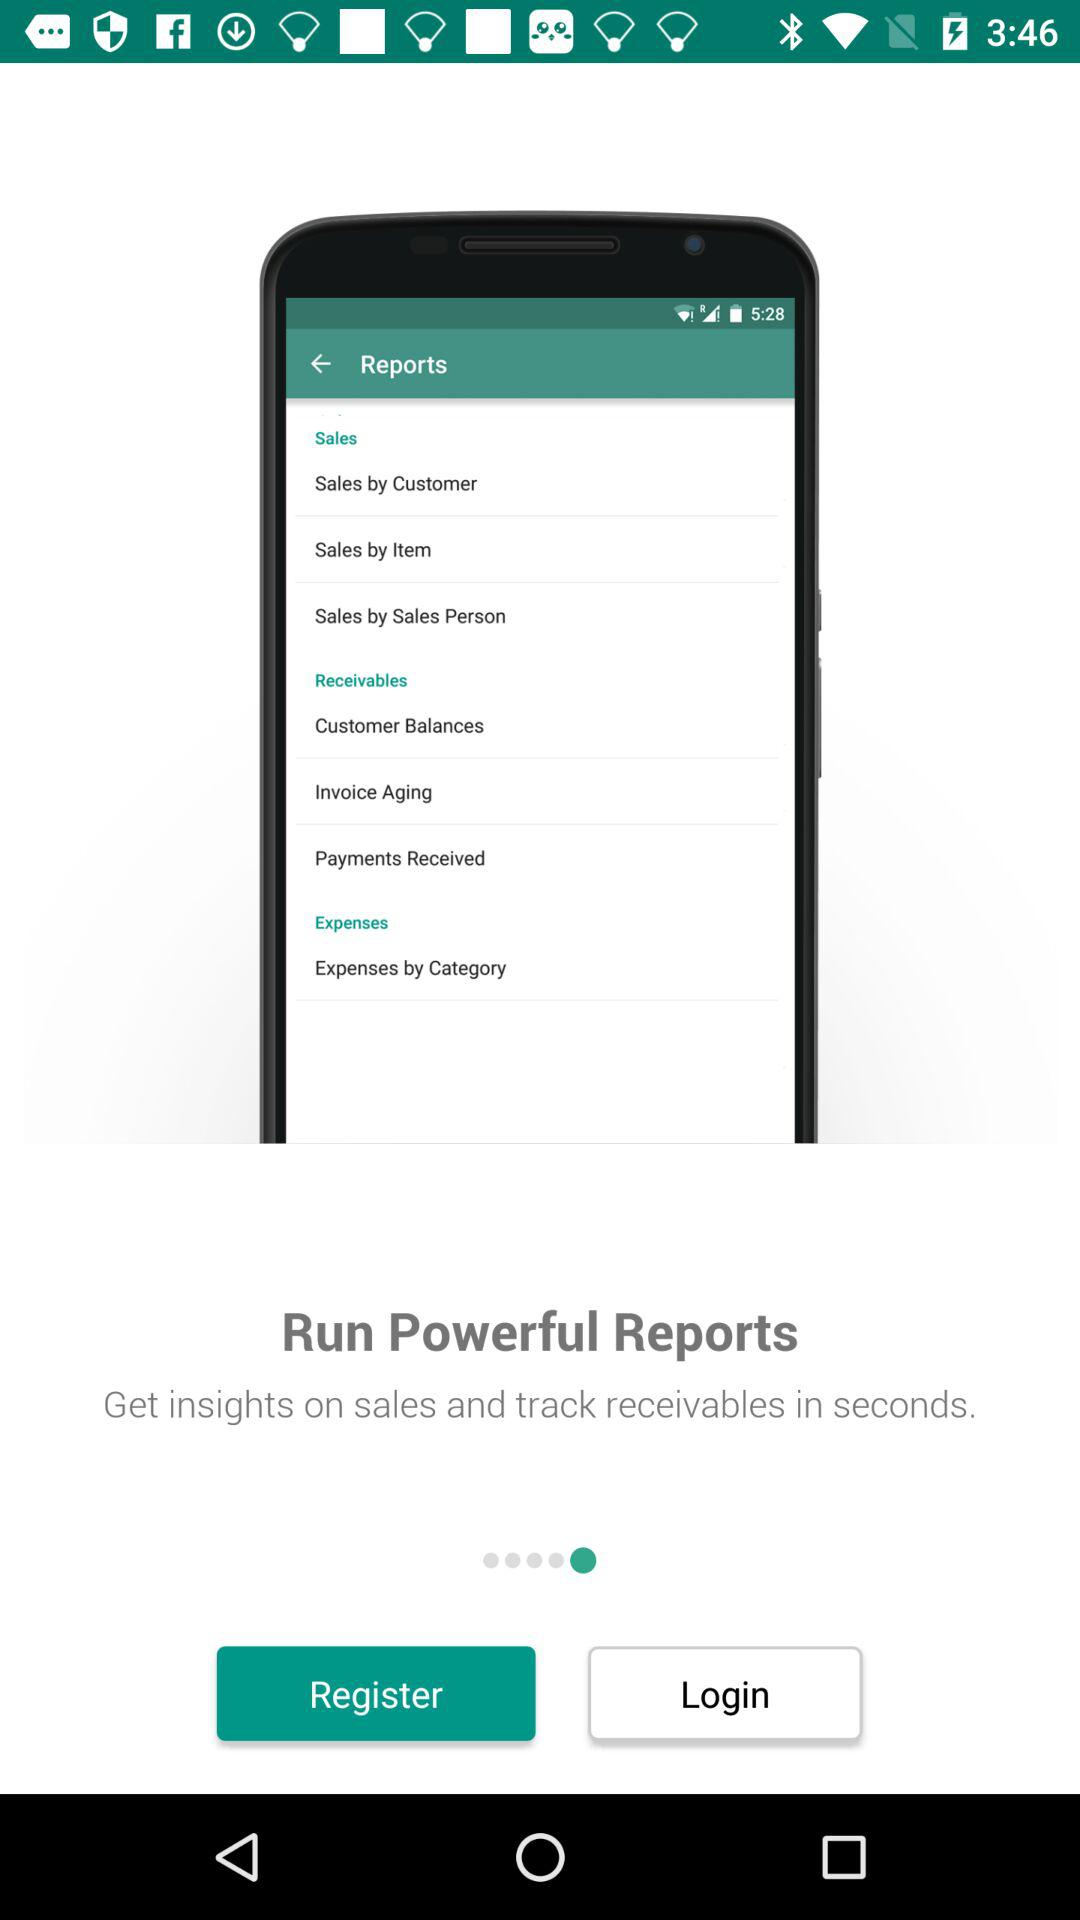Which type of start screen is selected?
When the provided information is insufficient, respond with <no answer>. <no answer> 